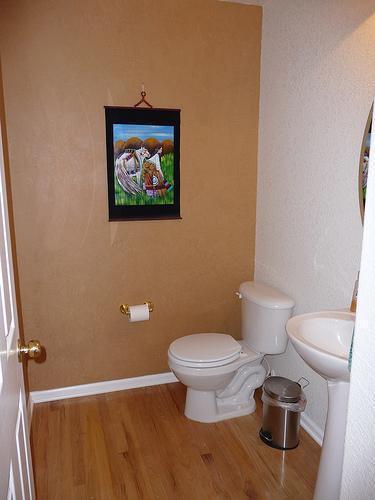How many colors is this room painted?
Give a very brief answer. 2. How many people are in the picture?
Give a very brief answer. 1. 